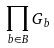Convert formula to latex. <formula><loc_0><loc_0><loc_500><loc_500>\prod _ { b \in B } G _ { b }</formula> 